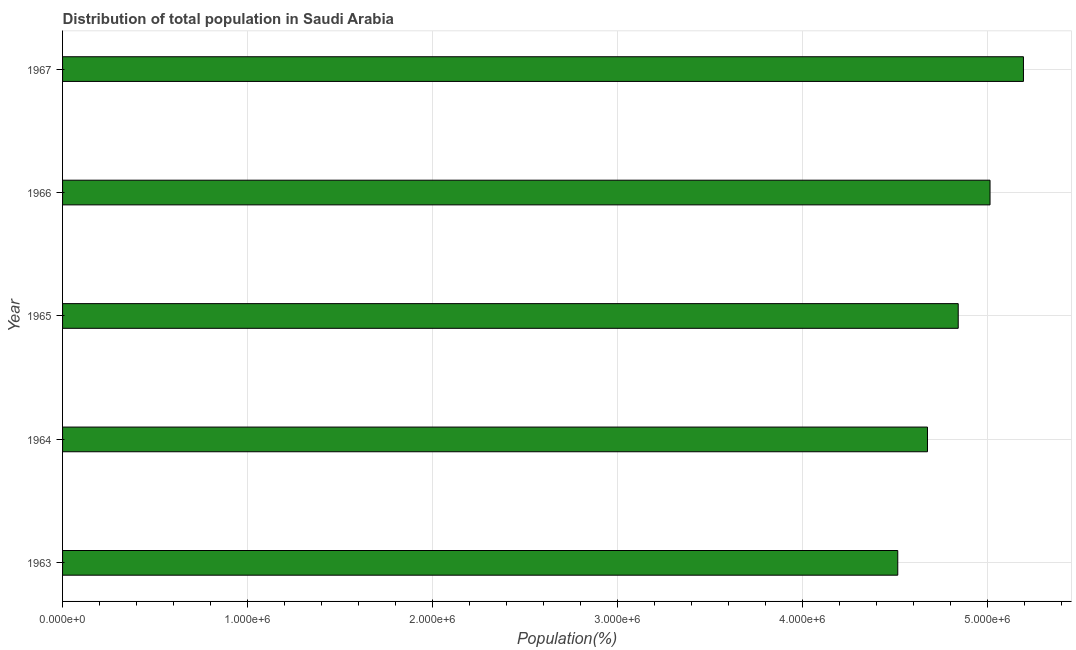Does the graph contain any zero values?
Provide a short and direct response. No. What is the title of the graph?
Offer a very short reply. Distribution of total population in Saudi Arabia . What is the label or title of the X-axis?
Make the answer very short. Population(%). What is the population in 1966?
Provide a succinct answer. 5.02e+06. Across all years, what is the maximum population?
Your answer should be compact. 5.20e+06. Across all years, what is the minimum population?
Your response must be concise. 4.52e+06. In which year was the population maximum?
Provide a succinct answer. 1967. What is the sum of the population?
Give a very brief answer. 2.42e+07. What is the difference between the population in 1963 and 1964?
Keep it short and to the point. -1.61e+05. What is the average population per year?
Your answer should be very brief. 4.85e+06. What is the median population?
Ensure brevity in your answer.  4.84e+06. In how many years, is the population greater than 800000 %?
Ensure brevity in your answer.  5. What is the ratio of the population in 1963 to that in 1966?
Your answer should be very brief. 0.9. Is the difference between the population in 1964 and 1965 greater than the difference between any two years?
Make the answer very short. No. What is the difference between the highest and the second highest population?
Ensure brevity in your answer.  1.81e+05. What is the difference between the highest and the lowest population?
Give a very brief answer. 6.80e+05. Are all the bars in the graph horizontal?
Your answer should be compact. Yes. How many years are there in the graph?
Your response must be concise. 5. What is the difference between two consecutive major ticks on the X-axis?
Ensure brevity in your answer.  1.00e+06. What is the Population(%) of 1963?
Your answer should be very brief. 4.52e+06. What is the Population(%) of 1964?
Provide a short and direct response. 4.68e+06. What is the Population(%) of 1965?
Give a very brief answer. 4.84e+06. What is the Population(%) of 1966?
Provide a succinct answer. 5.02e+06. What is the Population(%) in 1967?
Offer a very short reply. 5.20e+06. What is the difference between the Population(%) in 1963 and 1964?
Provide a short and direct response. -1.61e+05. What is the difference between the Population(%) in 1963 and 1965?
Ensure brevity in your answer.  -3.27e+05. What is the difference between the Population(%) in 1963 and 1966?
Your response must be concise. -4.99e+05. What is the difference between the Population(%) in 1963 and 1967?
Your response must be concise. -6.80e+05. What is the difference between the Population(%) in 1964 and 1965?
Ensure brevity in your answer.  -1.66e+05. What is the difference between the Population(%) in 1964 and 1966?
Provide a short and direct response. -3.38e+05. What is the difference between the Population(%) in 1964 and 1967?
Provide a short and direct response. -5.19e+05. What is the difference between the Population(%) in 1965 and 1966?
Provide a short and direct response. -1.72e+05. What is the difference between the Population(%) in 1965 and 1967?
Provide a short and direct response. -3.53e+05. What is the difference between the Population(%) in 1966 and 1967?
Ensure brevity in your answer.  -1.81e+05. What is the ratio of the Population(%) in 1963 to that in 1964?
Give a very brief answer. 0.97. What is the ratio of the Population(%) in 1963 to that in 1965?
Give a very brief answer. 0.93. What is the ratio of the Population(%) in 1963 to that in 1966?
Provide a short and direct response. 0.9. What is the ratio of the Population(%) in 1963 to that in 1967?
Give a very brief answer. 0.87. What is the ratio of the Population(%) in 1964 to that in 1965?
Offer a very short reply. 0.97. What is the ratio of the Population(%) in 1964 to that in 1966?
Offer a very short reply. 0.93. What is the ratio of the Population(%) in 1965 to that in 1966?
Offer a very short reply. 0.97. What is the ratio of the Population(%) in 1965 to that in 1967?
Provide a short and direct response. 0.93. 